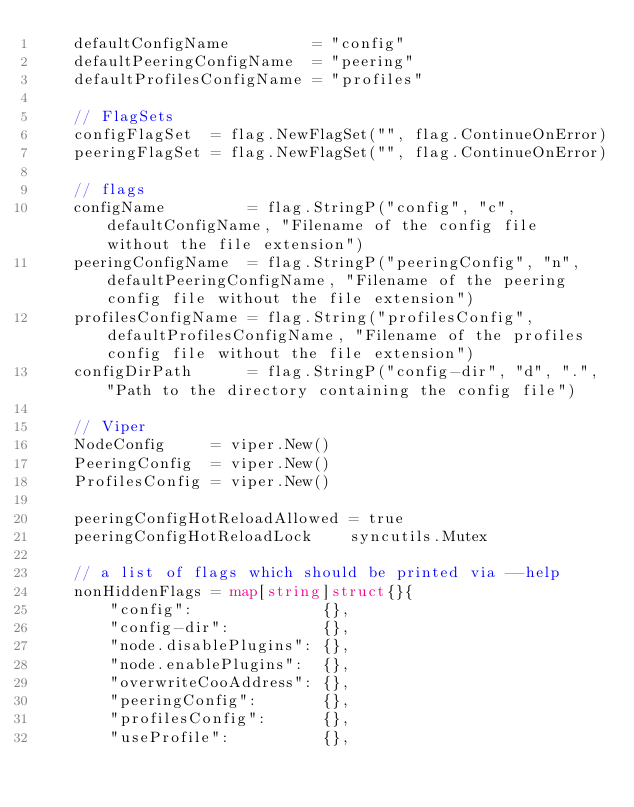<code> <loc_0><loc_0><loc_500><loc_500><_Go_>	defaultConfigName         = "config"
	defaultPeeringConfigName  = "peering"
	defaultProfilesConfigName = "profiles"

	// FlagSets
	configFlagSet  = flag.NewFlagSet("", flag.ContinueOnError)
	peeringFlagSet = flag.NewFlagSet("", flag.ContinueOnError)

	// flags
	configName         = flag.StringP("config", "c", defaultConfigName, "Filename of the config file without the file extension")
	peeringConfigName  = flag.StringP("peeringConfig", "n", defaultPeeringConfigName, "Filename of the peering config file without the file extension")
	profilesConfigName = flag.String("profilesConfig", defaultProfilesConfigName, "Filename of the profiles config file without the file extension")
	configDirPath      = flag.StringP("config-dir", "d", ".", "Path to the directory containing the config file")

	// Viper
	NodeConfig     = viper.New()
	PeeringConfig  = viper.New()
	ProfilesConfig = viper.New()

	peeringConfigHotReloadAllowed = true
	peeringConfigHotReloadLock    syncutils.Mutex

	// a list of flags which should be printed via --help
	nonHiddenFlags = map[string]struct{}{
		"config":              {},
		"config-dir":          {},
		"node.disablePlugins": {},
		"node.enablePlugins":  {},
		"overwriteCooAddress": {},
		"peeringConfig":       {},
		"profilesConfig":      {},
		"useProfile":          {},</code> 